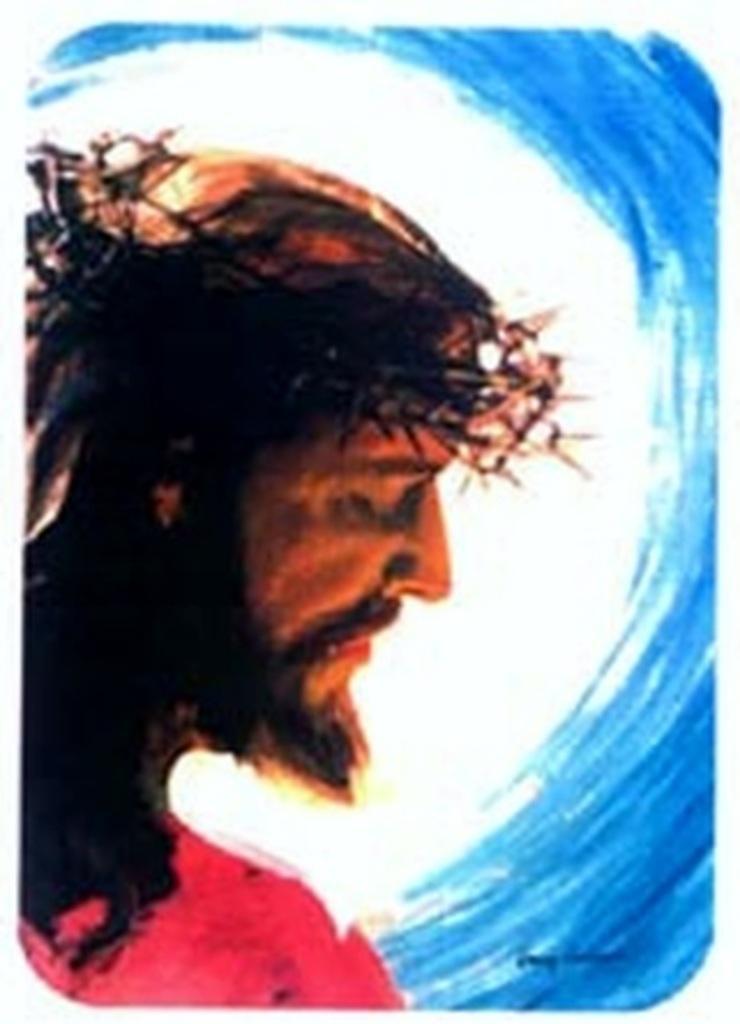Please provide a concise description of this image. In this image I see the depiction image of a man and it is white and blue color in the background. 